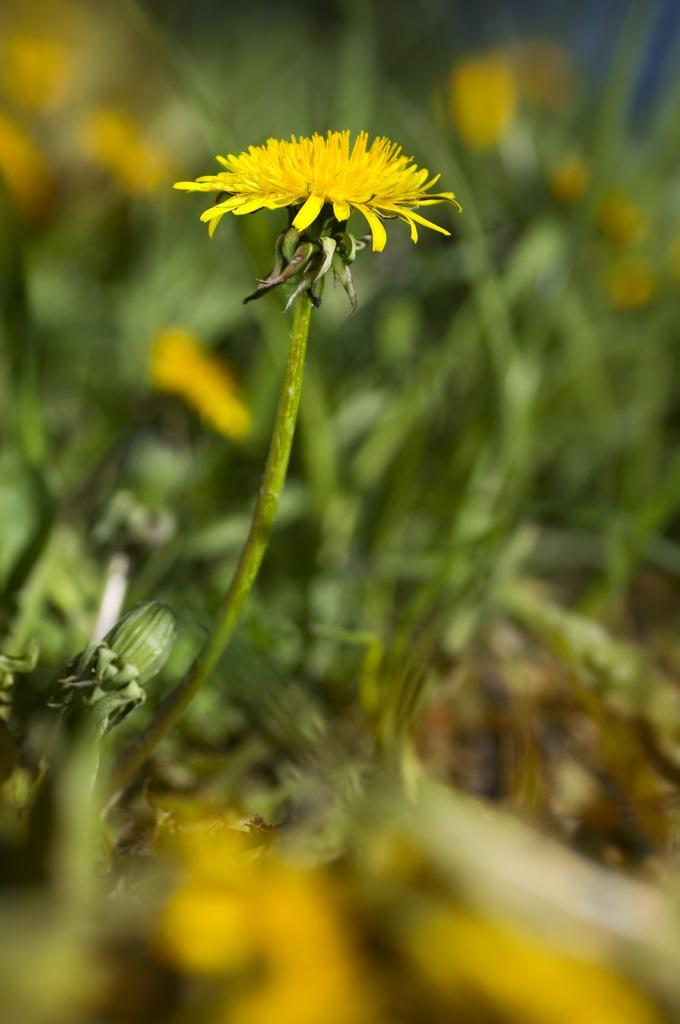What types of living organisms can be seen in the image? There are many plants in the image. What specific features can be observed on the plants? There are flowers on the plants in the image. What type of window can be seen in the image? There is no window present in the image; it features many plants with flowers. 